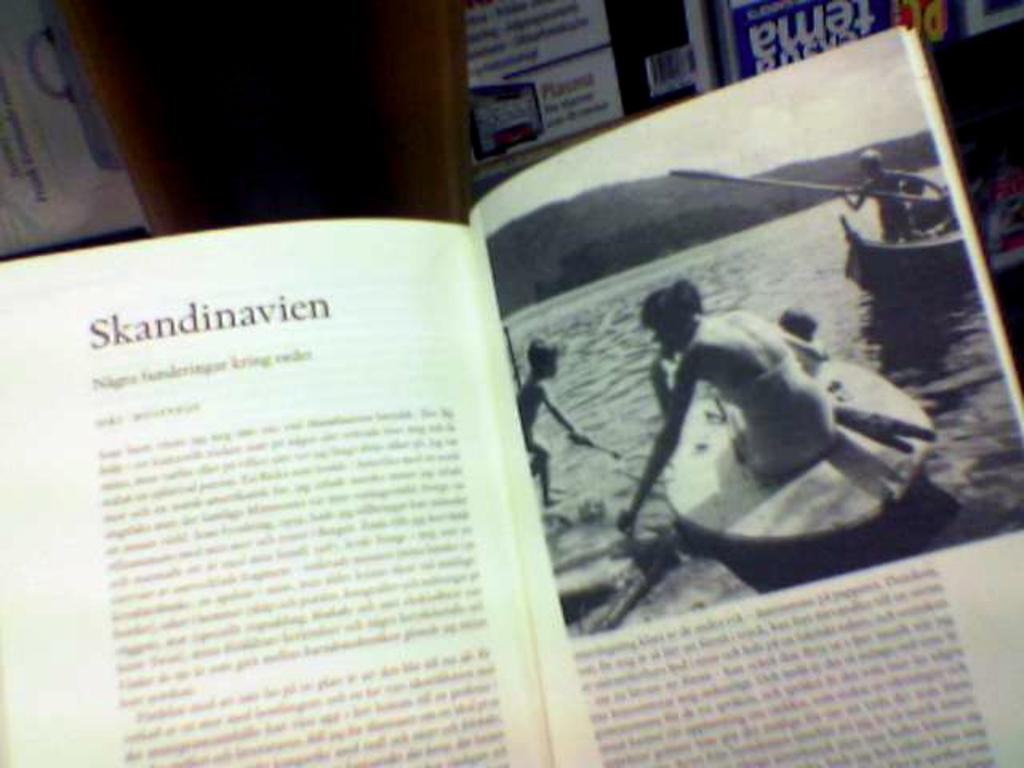<image>
Present a compact description of the photo's key features. A book is open to a page titled "Skandinavien" with a picture of people in boats on the opposite page. 